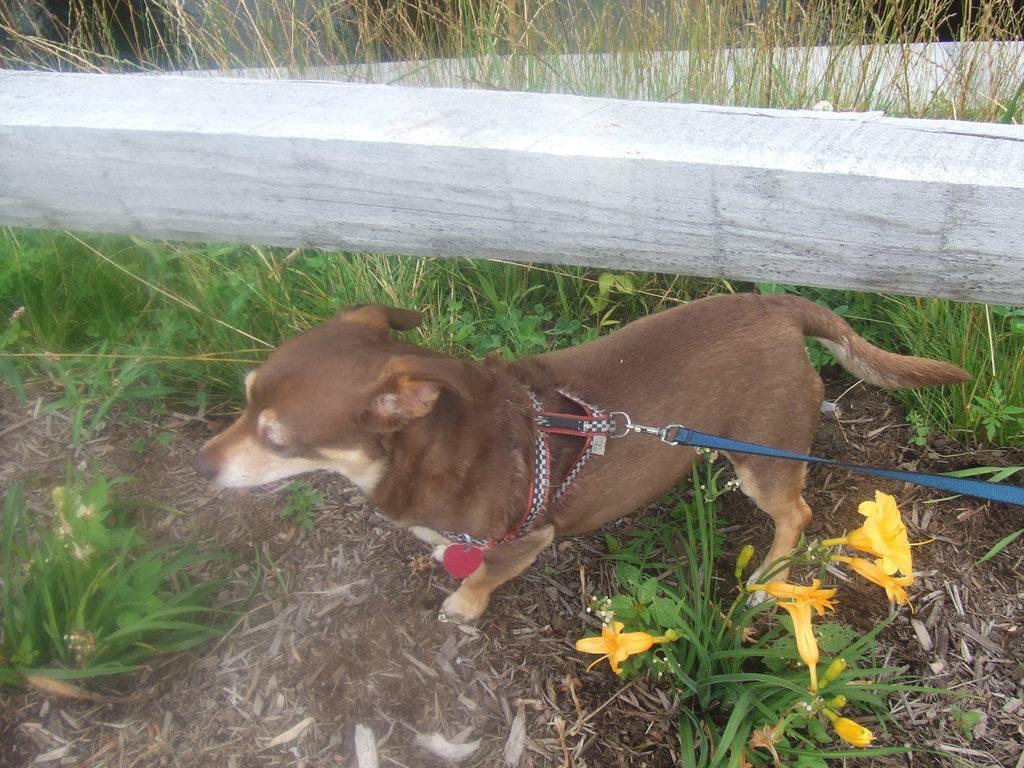Describe this image in one or two sentences. In this image I can see grass ground and on it I can see a brown colour dog is standing. On the bottom right side of this image I can see few yellow colour flowers and I can also see few belts on the dog. On the top of this image I can see few white colour things. 